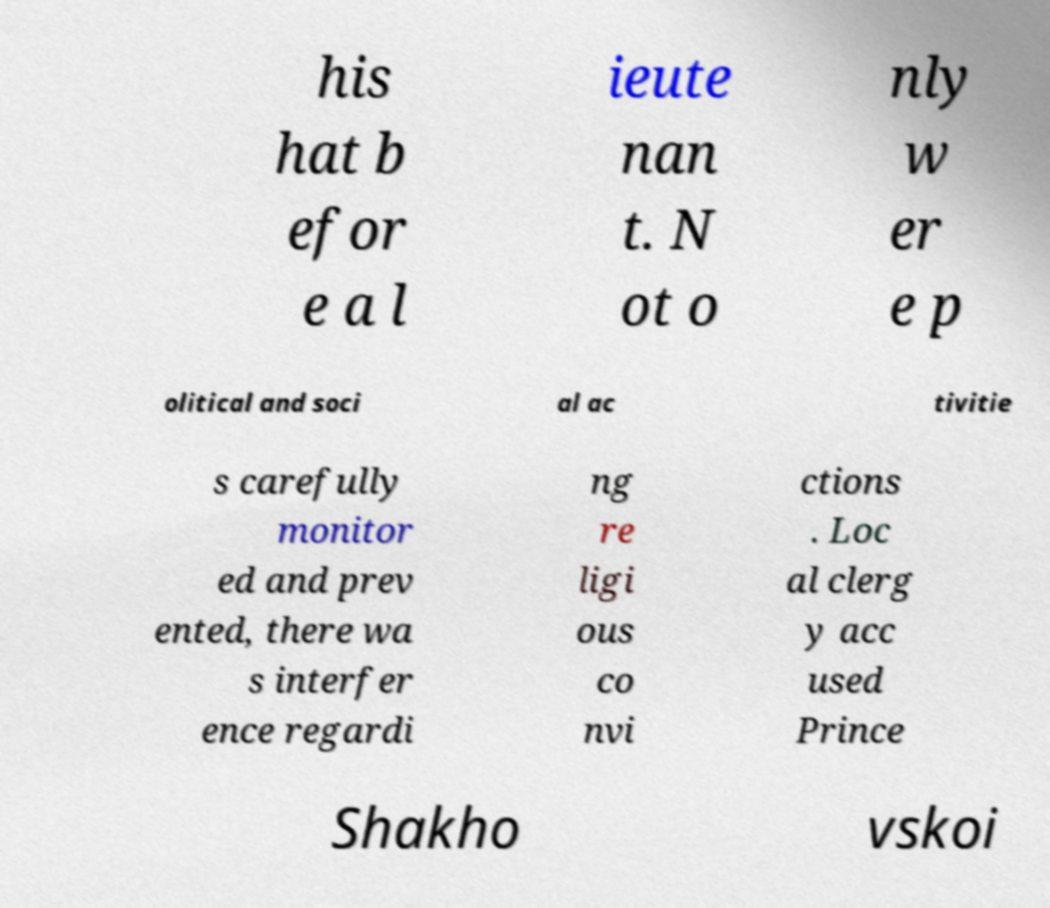Could you assist in decoding the text presented in this image and type it out clearly? his hat b efor e a l ieute nan t. N ot o nly w er e p olitical and soci al ac tivitie s carefully monitor ed and prev ented, there wa s interfer ence regardi ng re ligi ous co nvi ctions . Loc al clerg y acc used Prince Shakho vskoi 